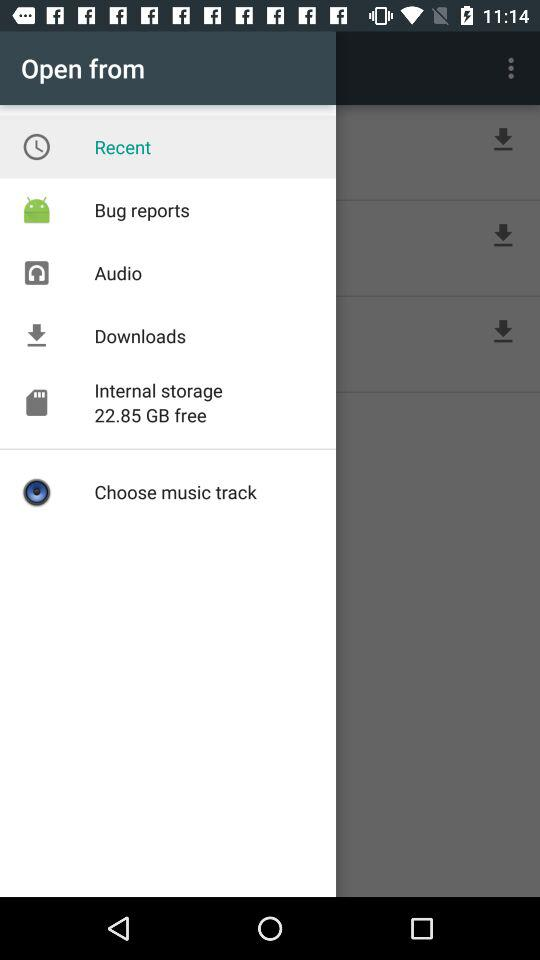How much free internal storage space is available? There is 22.85 GB of free internal storage available. 